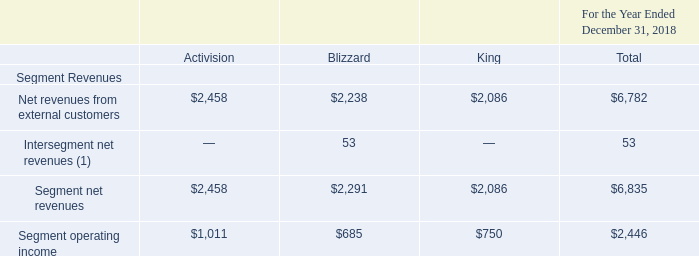Operating Segment Results
Currently, we have three reportable segments—Activision, Blizzard, and King. Our operating segments are consistent with the manner in which our operations are reviewed and managed by our Chief Executive Officer, who is our chief operating decision maker (“CODM”). The CODM reviews segment performance exclusive of: the impact of the change in deferred revenues and related cost of revenues with respect to certain of our online-enabled games; share-based compensation expense; amortization of intangible assets as a result of purchase price accounting; fees and other expenses (including legal fees, expenses, and accruals) related to acquisitions, associated integration activities, and financings; certain restructuring and related costs; and certain other non-cash charges. The CODM does not review any information regarding total assets on an operating segment basis, and accordingly, no disclosure is made with respect thereto.
Our operating segments are also consistent with our internal organizational structure, the way we assess operating performance and allocate resources, and the availability of separate financial information. We do not aggregate operating segments.
Information on the reportable segment net revenues and segment operating income are presented below (amounts in millions):
(1) Intersegment revenues reflect licensing and service fees charged between segments.
What is the Net revenues from external customers from Activision?
Answer scale should be: million. $2,458. What is the Net revenues from external customers from Blizzard?
Answer scale should be: million. $2,238. What is the total Segment net revenues?
Answer scale should be: million. $6,835. What is the difference in Net revenues from external customers between Activision and Blizzard?
Answer scale should be: million. ($2,458-$2,238)
Answer: 220. What percentage of the total Net revenues from external customers does King contribute?
Answer scale should be: percent. ($2,086/$6,782)
Answer: 30.76. What is the total segment operating income of Activision and King?
Answer scale should be: million. $1,011+$750
Answer: 1761. 